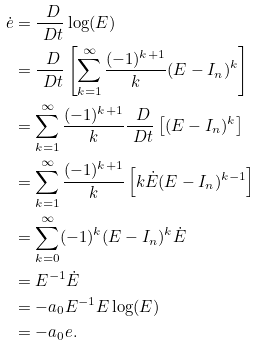Convert formula to latex. <formula><loc_0><loc_0><loc_500><loc_500>\dot { e } & = \frac { \ D } { \ D t } \log ( E ) \\ & = \frac { \ D } { \ D t } \left [ \sum _ { k = 1 } ^ { \infty } \frac { ( - 1 ) ^ { k + 1 } } { k } ( E - I _ { n } ) ^ { k } \right ] \\ & = \sum _ { k = 1 } ^ { \infty } \frac { ( - 1 ) ^ { k + 1 } } { k } \frac { \ D } { \ D t } \left [ ( E - I _ { n } ) ^ { k } \right ] \\ & = \sum _ { k = 1 } ^ { \infty } \frac { ( - 1 ) ^ { k + 1 } } { k } \left [ k \dot { E } ( E - I _ { n } ) ^ { k - 1 } \right ] \\ & = \sum _ { k = 0 } ^ { \infty } ( - 1 ) ^ { k } ( E - I _ { n } ) ^ { k } \dot { E } \\ & = E ^ { - 1 } \dot { E } \\ & = - a _ { 0 } E ^ { - 1 } E \log ( E ) \\ & = - a _ { 0 } e .</formula> 